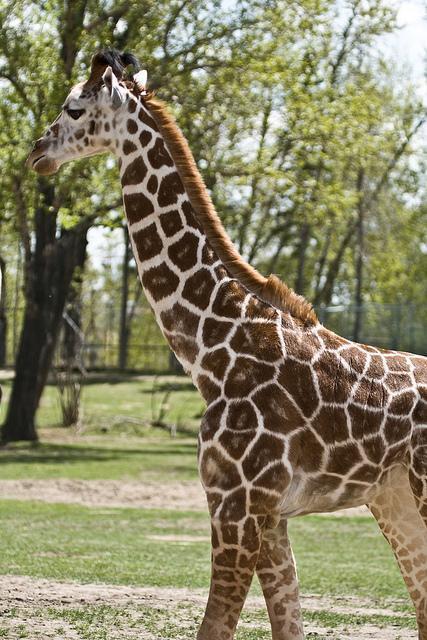How many giraffes can be seen?
Give a very brief answer. 1. 